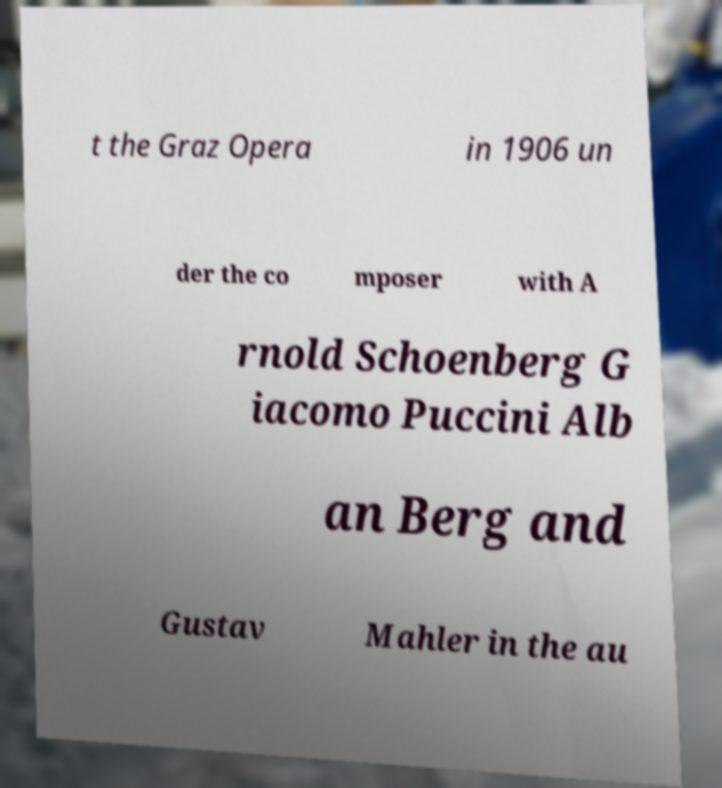Can you accurately transcribe the text from the provided image for me? t the Graz Opera in 1906 un der the co mposer with A rnold Schoenberg G iacomo Puccini Alb an Berg and Gustav Mahler in the au 